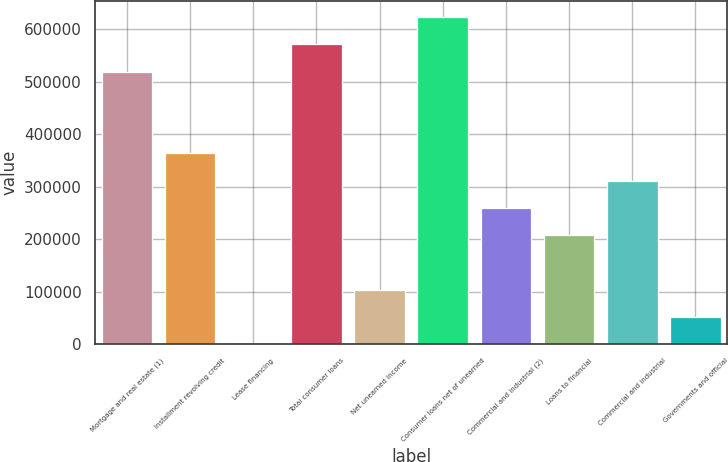Convert chart to OTSL. <chart><loc_0><loc_0><loc_500><loc_500><bar_chart><fcel>Mortgage and real estate (1)<fcel>Installment revolving credit<fcel>Lease financing<fcel>Total consumer loans<fcel>Net unearned income<fcel>Consumer loans net of unearned<fcel>Commercial and industrial (2)<fcel>Loans to financial<fcel>Commercial and industrial<fcel>Governments and official<nl><fcel>519673<fcel>363780<fcel>31<fcel>571637<fcel>103959<fcel>623601<fcel>259852<fcel>207888<fcel>311816<fcel>51995.2<nl></chart> 